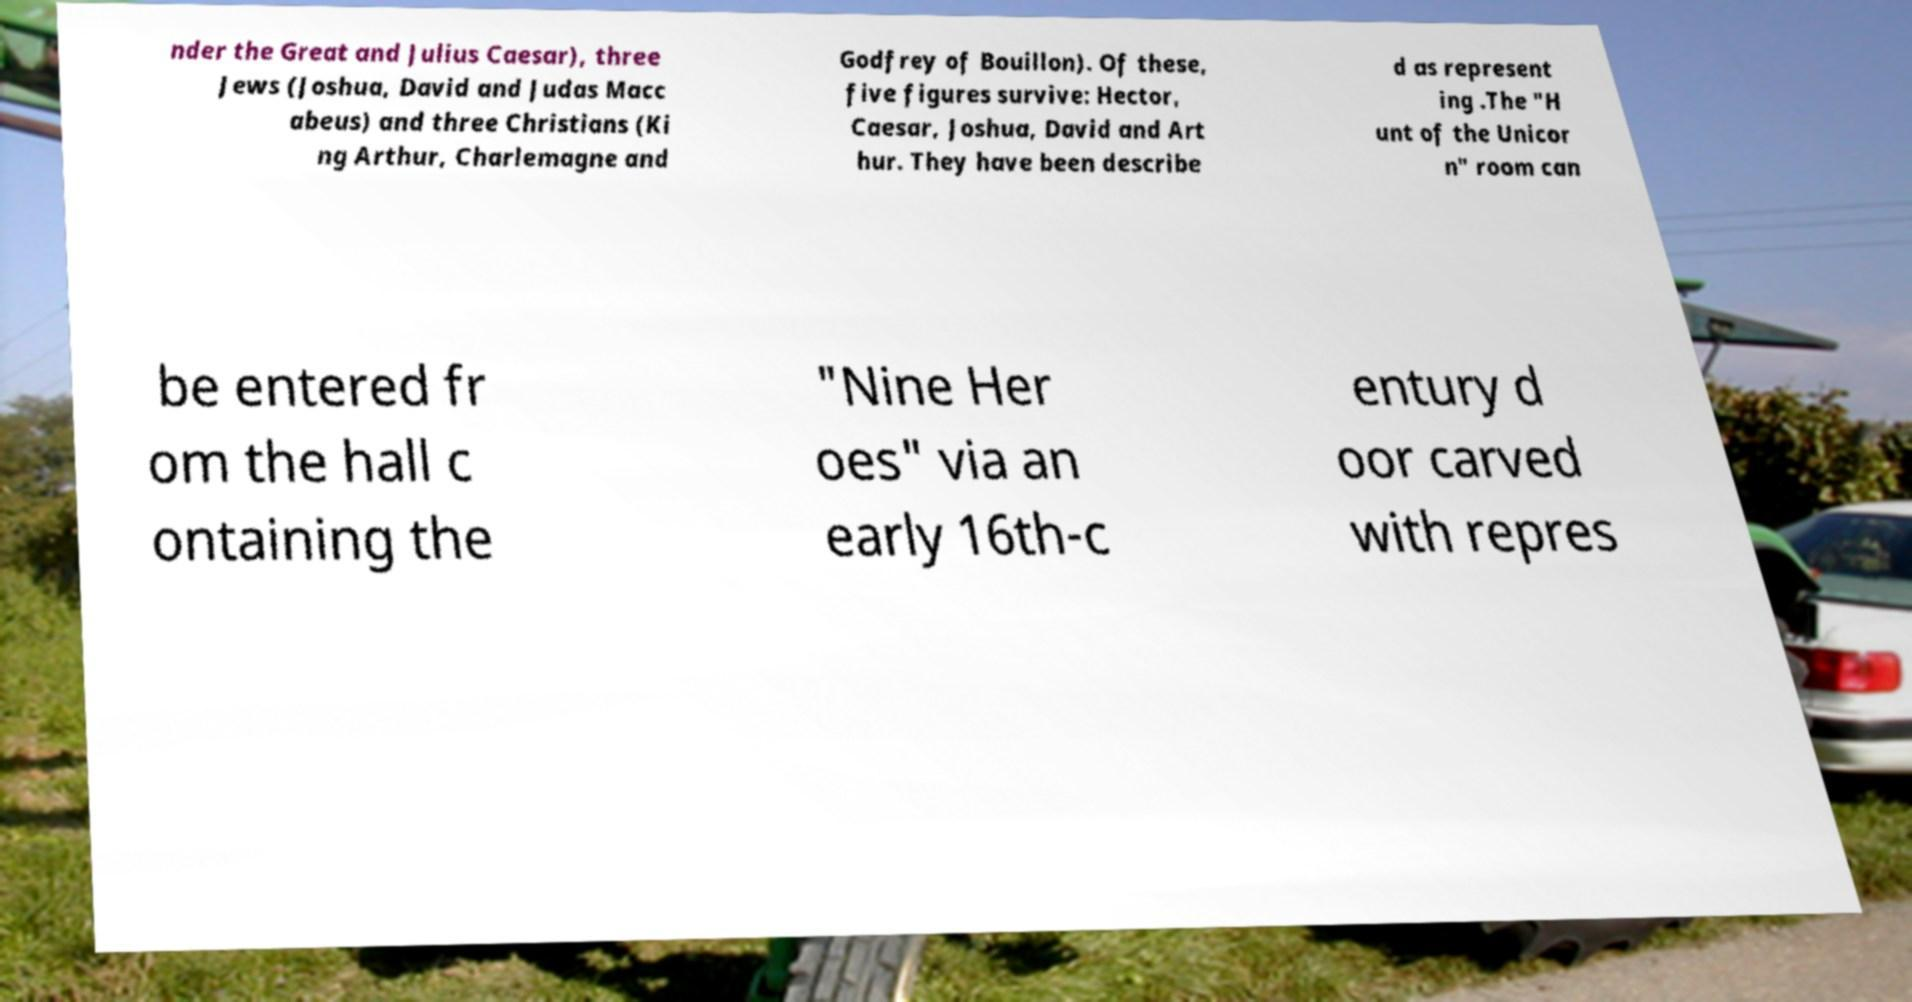For documentation purposes, I need the text within this image transcribed. Could you provide that? nder the Great and Julius Caesar), three Jews (Joshua, David and Judas Macc abeus) and three Christians (Ki ng Arthur, Charlemagne and Godfrey of Bouillon). Of these, five figures survive: Hector, Caesar, Joshua, David and Art hur. They have been describe d as represent ing .The "H unt of the Unicor n" room can be entered fr om the hall c ontaining the "Nine Her oes" via an early 16th-c entury d oor carved with repres 